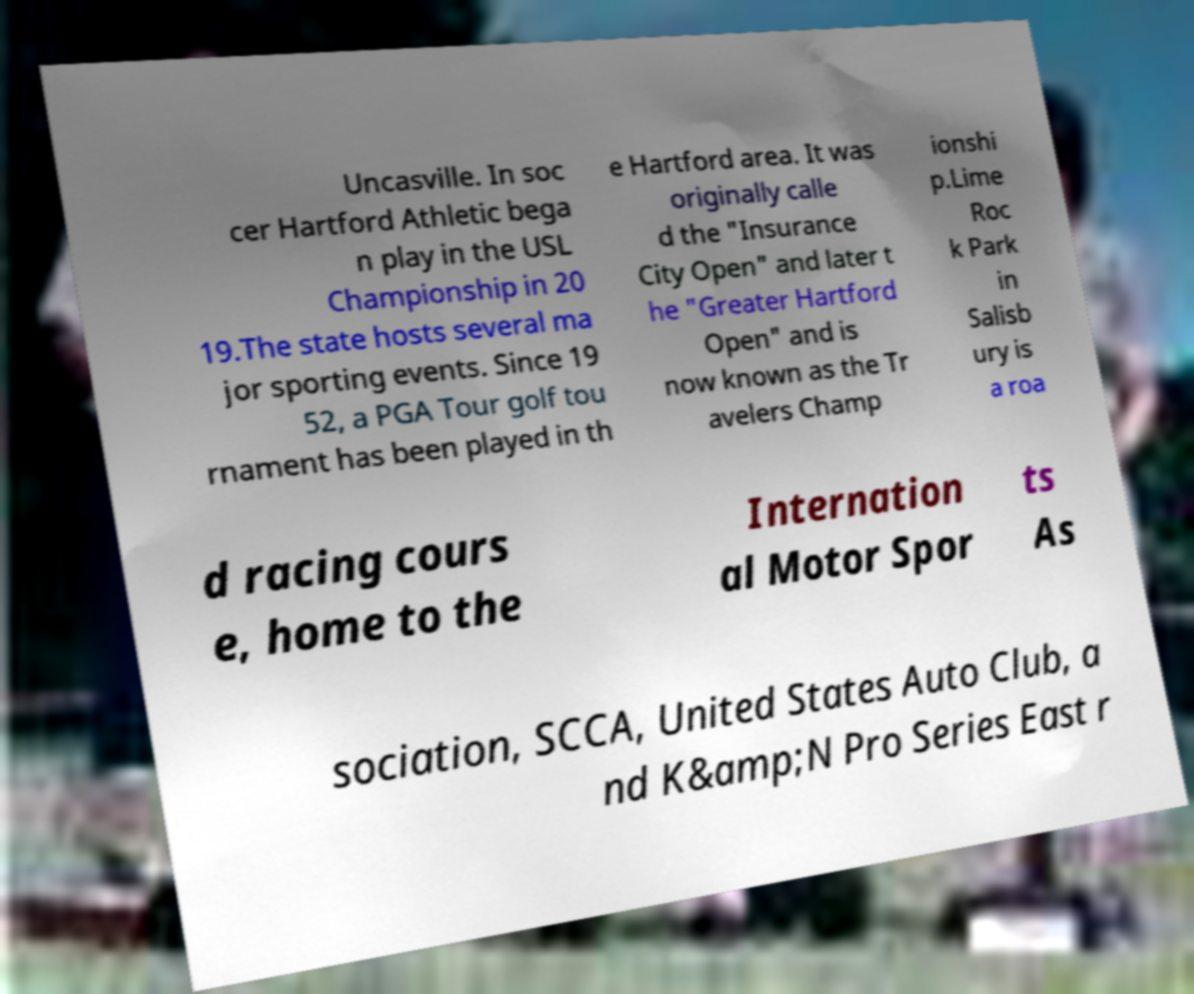Can you read and provide the text displayed in the image?This photo seems to have some interesting text. Can you extract and type it out for me? Uncasville. In soc cer Hartford Athletic bega n play in the USL Championship in 20 19.The state hosts several ma jor sporting events. Since 19 52, a PGA Tour golf tou rnament has been played in th e Hartford area. It was originally calle d the "Insurance City Open" and later t he "Greater Hartford Open" and is now known as the Tr avelers Champ ionshi p.Lime Roc k Park in Salisb ury is a roa d racing cours e, home to the Internation al Motor Spor ts As sociation, SCCA, United States Auto Club, a nd K&amp;N Pro Series East r 